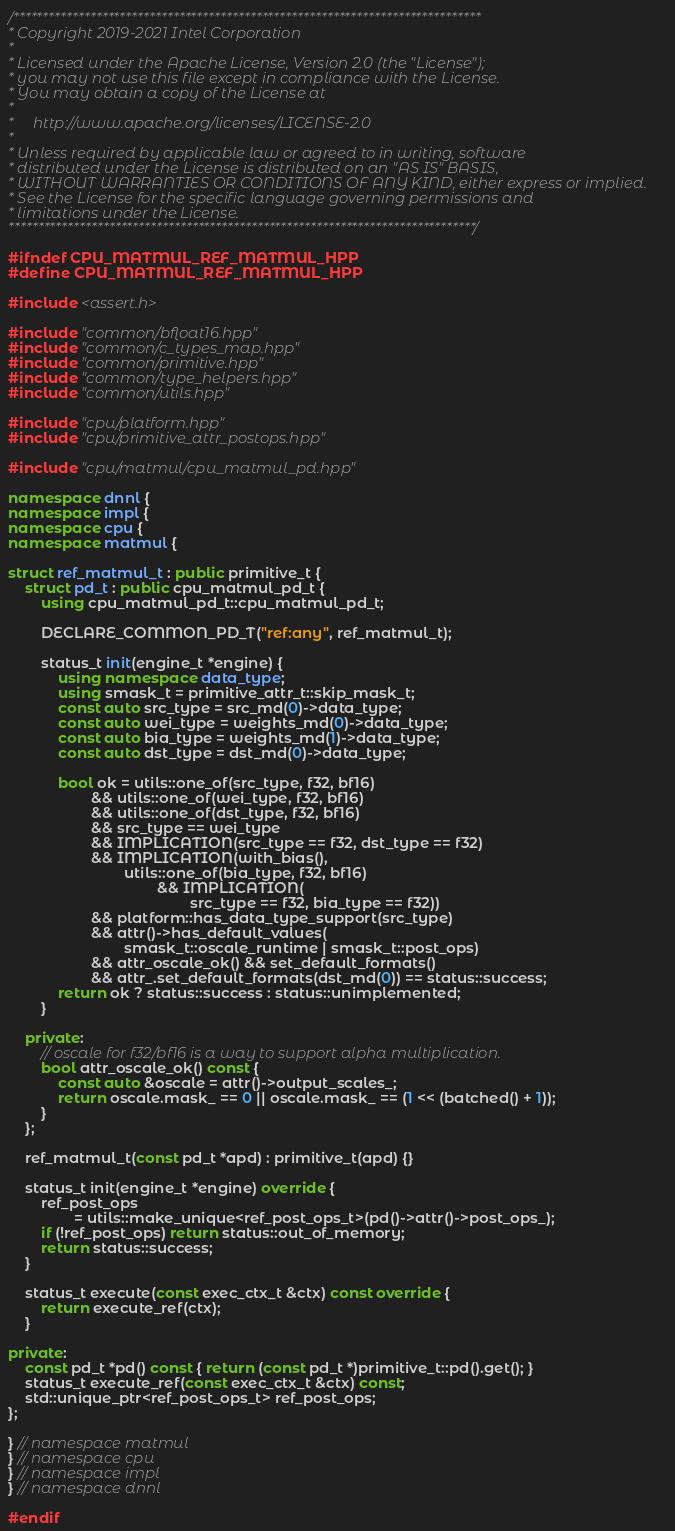<code> <loc_0><loc_0><loc_500><loc_500><_C++_>/*******************************************************************************
* Copyright 2019-2021 Intel Corporation
*
* Licensed under the Apache License, Version 2.0 (the "License");
* you may not use this file except in compliance with the License.
* You may obtain a copy of the License at
*
*     http://www.apache.org/licenses/LICENSE-2.0
*
* Unless required by applicable law or agreed to in writing, software
* distributed under the License is distributed on an "AS IS" BASIS,
* WITHOUT WARRANTIES OR CONDITIONS OF ANY KIND, either express or implied.
* See the License for the specific language governing permissions and
* limitations under the License.
*******************************************************************************/

#ifndef CPU_MATMUL_REF_MATMUL_HPP
#define CPU_MATMUL_REF_MATMUL_HPP

#include <assert.h>

#include "common/bfloat16.hpp"
#include "common/c_types_map.hpp"
#include "common/primitive.hpp"
#include "common/type_helpers.hpp"
#include "common/utils.hpp"

#include "cpu/platform.hpp"
#include "cpu/primitive_attr_postops.hpp"

#include "cpu/matmul/cpu_matmul_pd.hpp"

namespace dnnl {
namespace impl {
namespace cpu {
namespace matmul {

struct ref_matmul_t : public primitive_t {
    struct pd_t : public cpu_matmul_pd_t {
        using cpu_matmul_pd_t::cpu_matmul_pd_t;

        DECLARE_COMMON_PD_T("ref:any", ref_matmul_t);

        status_t init(engine_t *engine) {
            using namespace data_type;
            using smask_t = primitive_attr_t::skip_mask_t;
            const auto src_type = src_md(0)->data_type;
            const auto wei_type = weights_md(0)->data_type;
            const auto bia_type = weights_md(1)->data_type;
            const auto dst_type = dst_md(0)->data_type;

            bool ok = utils::one_of(src_type, f32, bf16)
                    && utils::one_of(wei_type, f32, bf16)
                    && utils::one_of(dst_type, f32, bf16)
                    && src_type == wei_type
                    && IMPLICATION(src_type == f32, dst_type == f32)
                    && IMPLICATION(with_bias(),
                            utils::one_of(bia_type, f32, bf16)
                                    && IMPLICATION(
                                            src_type == f32, bia_type == f32))
                    && platform::has_data_type_support(src_type)
                    && attr()->has_default_values(
                            smask_t::oscale_runtime | smask_t::post_ops)
                    && attr_oscale_ok() && set_default_formats()
                    && attr_.set_default_formats(dst_md(0)) == status::success;
            return ok ? status::success : status::unimplemented;
        }

    private:
        // oscale for f32/bf16 is a way to support alpha multiplication.
        bool attr_oscale_ok() const {
            const auto &oscale = attr()->output_scales_;
            return oscale.mask_ == 0 || oscale.mask_ == (1 << (batched() + 1));
        }
    };

    ref_matmul_t(const pd_t *apd) : primitive_t(apd) {}

    status_t init(engine_t *engine) override {
        ref_post_ops
                = utils::make_unique<ref_post_ops_t>(pd()->attr()->post_ops_);
        if (!ref_post_ops) return status::out_of_memory;
        return status::success;
    }

    status_t execute(const exec_ctx_t &ctx) const override {
        return execute_ref(ctx);
    }

private:
    const pd_t *pd() const { return (const pd_t *)primitive_t::pd().get(); }
    status_t execute_ref(const exec_ctx_t &ctx) const;
    std::unique_ptr<ref_post_ops_t> ref_post_ops;
};

} // namespace matmul
} // namespace cpu
} // namespace impl
} // namespace dnnl

#endif
</code> 